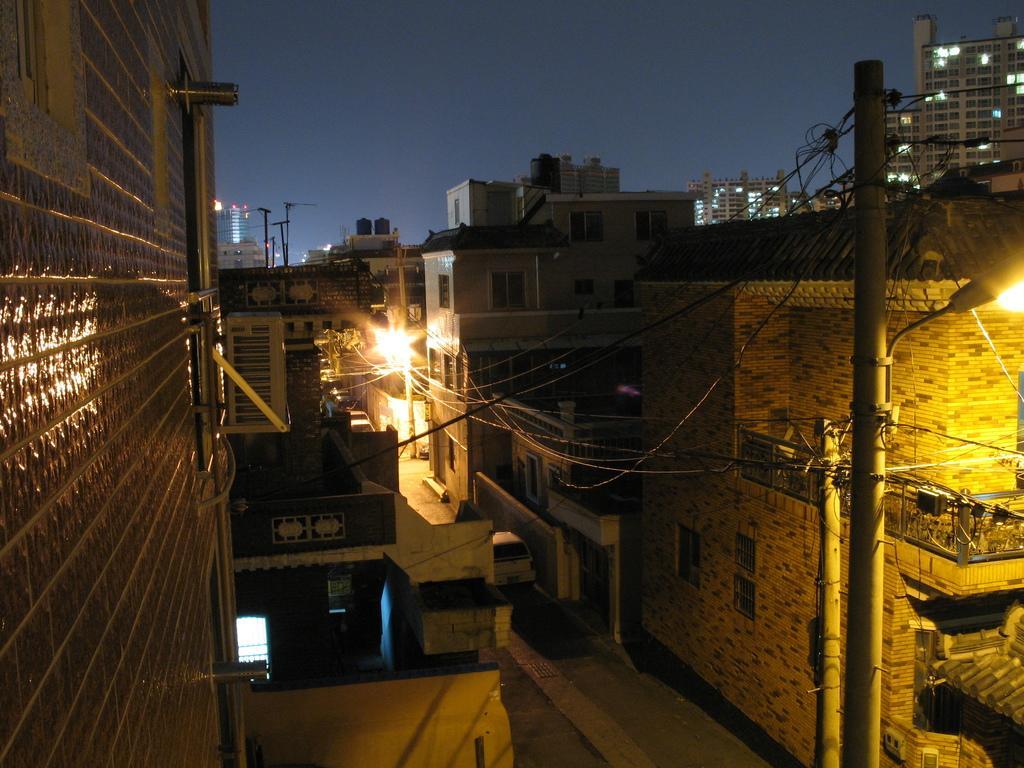Please provide a concise description of this image. In this image there is the sky towards the top of the image, there are buildings, there is road towards the bottom of the image, there are poles towards the bottom of the image, there are wires, there are street lights, there is a wall towards the left of the image, there is a wall towards the bottom of the image. 